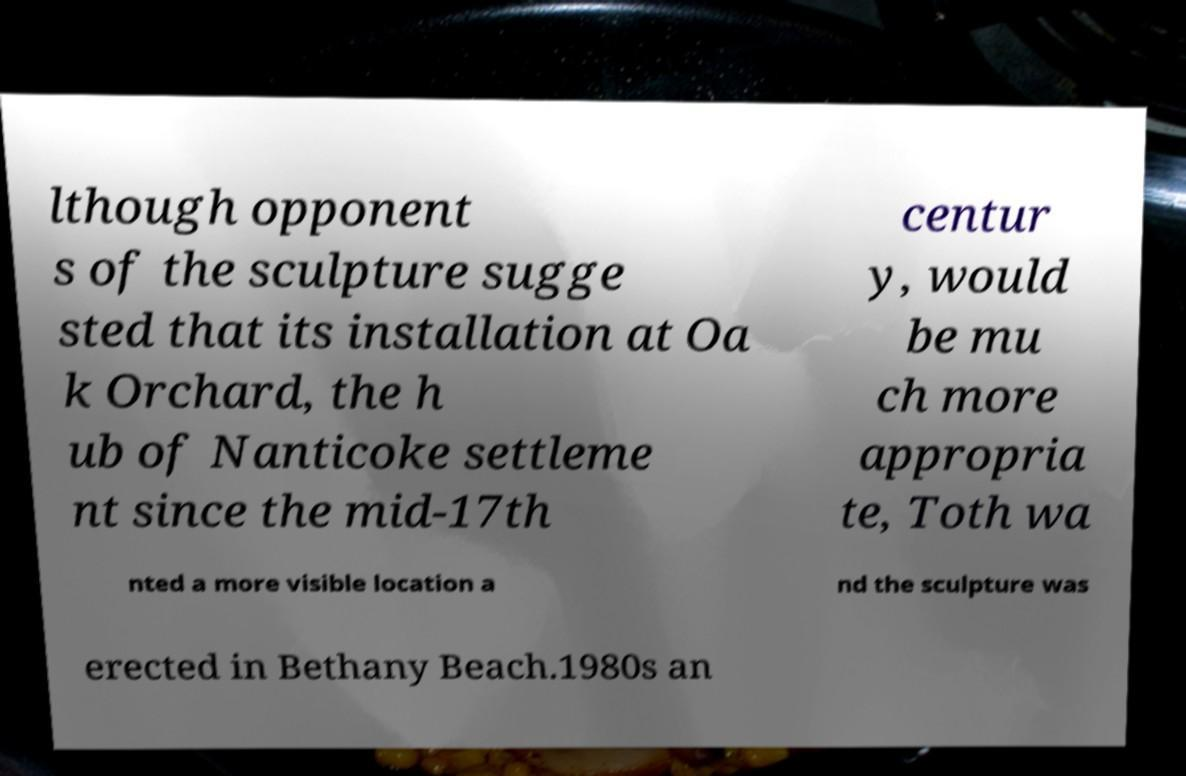I need the written content from this picture converted into text. Can you do that? lthough opponent s of the sculpture sugge sted that its installation at Oa k Orchard, the h ub of Nanticoke settleme nt since the mid-17th centur y, would be mu ch more appropria te, Toth wa nted a more visible location a nd the sculpture was erected in Bethany Beach.1980s an 